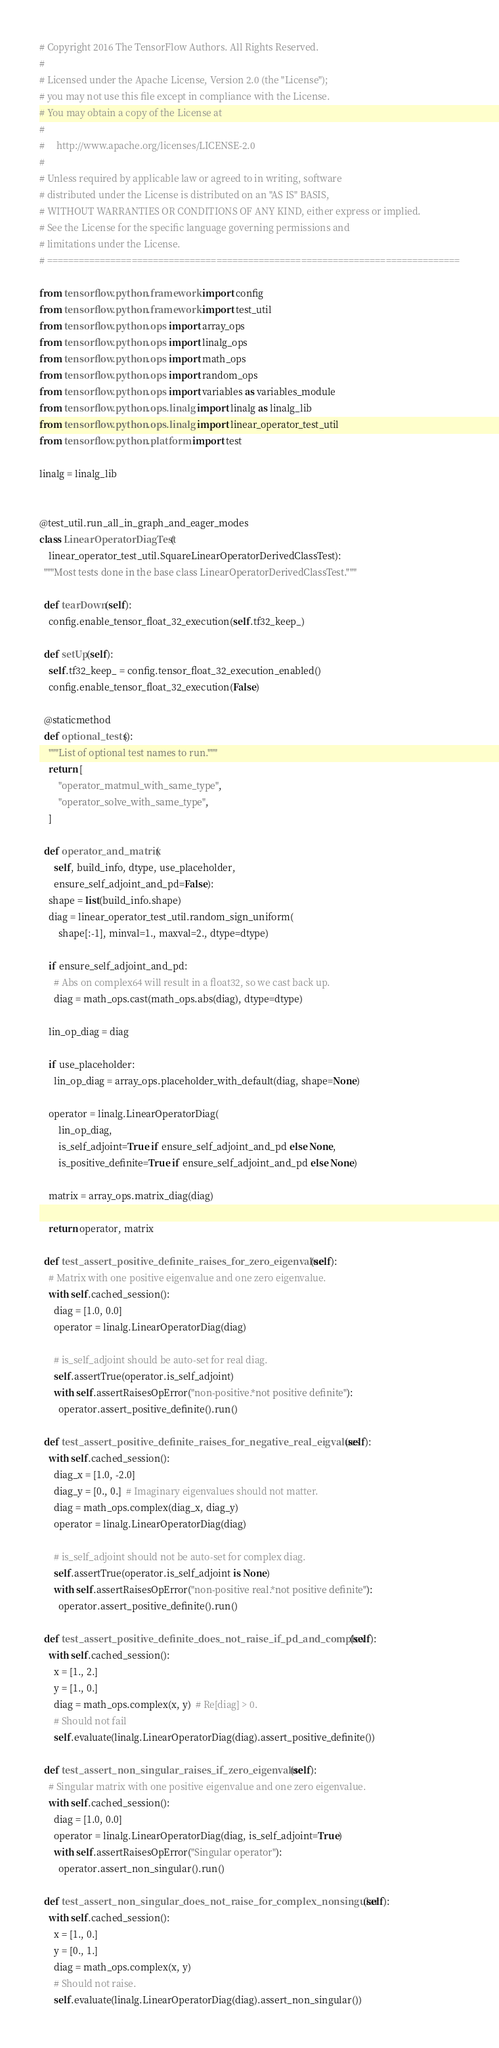Convert code to text. <code><loc_0><loc_0><loc_500><loc_500><_Python_># Copyright 2016 The TensorFlow Authors. All Rights Reserved.
#
# Licensed under the Apache License, Version 2.0 (the "License");
# you may not use this file except in compliance with the License.
# You may obtain a copy of the License at
#
#     http://www.apache.org/licenses/LICENSE-2.0
#
# Unless required by applicable law or agreed to in writing, software
# distributed under the License is distributed on an "AS IS" BASIS,
# WITHOUT WARRANTIES OR CONDITIONS OF ANY KIND, either express or implied.
# See the License for the specific language governing permissions and
# limitations under the License.
# ==============================================================================

from tensorflow.python.framework import config
from tensorflow.python.framework import test_util
from tensorflow.python.ops import array_ops
from tensorflow.python.ops import linalg_ops
from tensorflow.python.ops import math_ops
from tensorflow.python.ops import random_ops
from tensorflow.python.ops import variables as variables_module
from tensorflow.python.ops.linalg import linalg as linalg_lib
from tensorflow.python.ops.linalg import linear_operator_test_util
from tensorflow.python.platform import test

linalg = linalg_lib


@test_util.run_all_in_graph_and_eager_modes
class LinearOperatorDiagTest(
    linear_operator_test_util.SquareLinearOperatorDerivedClassTest):
  """Most tests done in the base class LinearOperatorDerivedClassTest."""

  def tearDown(self):
    config.enable_tensor_float_32_execution(self.tf32_keep_)

  def setUp(self):
    self.tf32_keep_ = config.tensor_float_32_execution_enabled()
    config.enable_tensor_float_32_execution(False)

  @staticmethod
  def optional_tests():
    """List of optional test names to run."""
    return [
        "operator_matmul_with_same_type",
        "operator_solve_with_same_type",
    ]

  def operator_and_matrix(
      self, build_info, dtype, use_placeholder,
      ensure_self_adjoint_and_pd=False):
    shape = list(build_info.shape)
    diag = linear_operator_test_util.random_sign_uniform(
        shape[:-1], minval=1., maxval=2., dtype=dtype)

    if ensure_self_adjoint_and_pd:
      # Abs on complex64 will result in a float32, so we cast back up.
      diag = math_ops.cast(math_ops.abs(diag), dtype=dtype)

    lin_op_diag = diag

    if use_placeholder:
      lin_op_diag = array_ops.placeholder_with_default(diag, shape=None)

    operator = linalg.LinearOperatorDiag(
        lin_op_diag,
        is_self_adjoint=True if ensure_self_adjoint_and_pd else None,
        is_positive_definite=True if ensure_self_adjoint_and_pd else None)

    matrix = array_ops.matrix_diag(diag)

    return operator, matrix

  def test_assert_positive_definite_raises_for_zero_eigenvalue(self):
    # Matrix with one positive eigenvalue and one zero eigenvalue.
    with self.cached_session():
      diag = [1.0, 0.0]
      operator = linalg.LinearOperatorDiag(diag)

      # is_self_adjoint should be auto-set for real diag.
      self.assertTrue(operator.is_self_adjoint)
      with self.assertRaisesOpError("non-positive.*not positive definite"):
        operator.assert_positive_definite().run()

  def test_assert_positive_definite_raises_for_negative_real_eigvalues(self):
    with self.cached_session():
      diag_x = [1.0, -2.0]
      diag_y = [0., 0.]  # Imaginary eigenvalues should not matter.
      diag = math_ops.complex(diag_x, diag_y)
      operator = linalg.LinearOperatorDiag(diag)

      # is_self_adjoint should not be auto-set for complex diag.
      self.assertTrue(operator.is_self_adjoint is None)
      with self.assertRaisesOpError("non-positive real.*not positive definite"):
        operator.assert_positive_definite().run()

  def test_assert_positive_definite_does_not_raise_if_pd_and_complex(self):
    with self.cached_session():
      x = [1., 2.]
      y = [1., 0.]
      diag = math_ops.complex(x, y)  # Re[diag] > 0.
      # Should not fail
      self.evaluate(linalg.LinearOperatorDiag(diag).assert_positive_definite())

  def test_assert_non_singular_raises_if_zero_eigenvalue(self):
    # Singular matrix with one positive eigenvalue and one zero eigenvalue.
    with self.cached_session():
      diag = [1.0, 0.0]
      operator = linalg.LinearOperatorDiag(diag, is_self_adjoint=True)
      with self.assertRaisesOpError("Singular operator"):
        operator.assert_non_singular().run()

  def test_assert_non_singular_does_not_raise_for_complex_nonsingular(self):
    with self.cached_session():
      x = [1., 0.]
      y = [0., 1.]
      diag = math_ops.complex(x, y)
      # Should not raise.
      self.evaluate(linalg.LinearOperatorDiag(diag).assert_non_singular())
</code> 